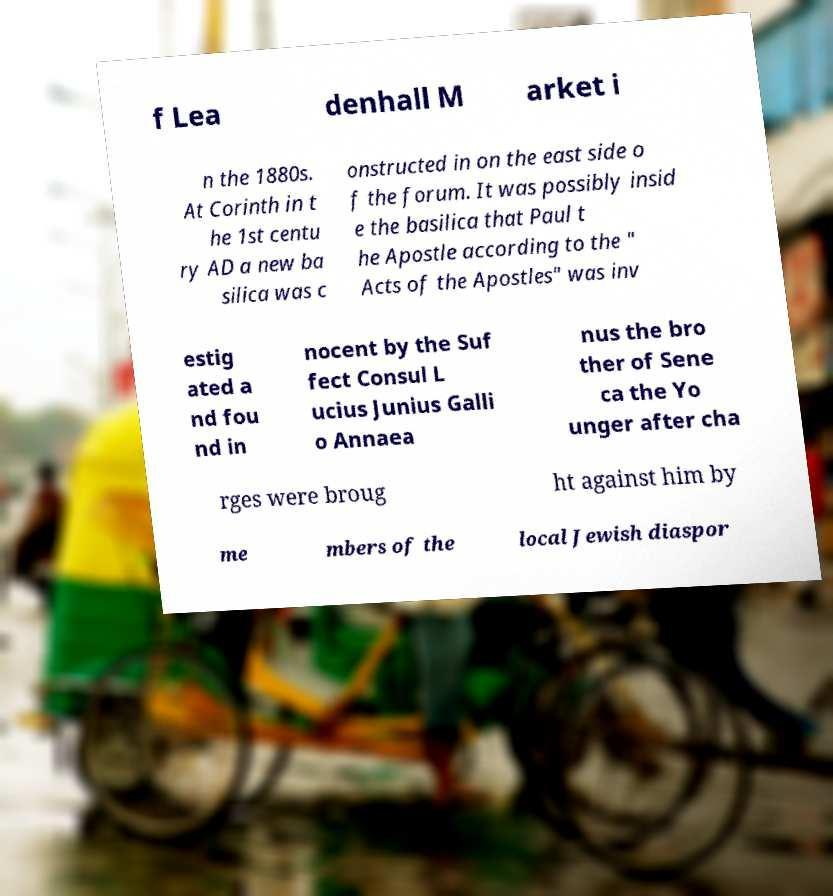Can you accurately transcribe the text from the provided image for me? f Lea denhall M arket i n the 1880s. At Corinth in t he 1st centu ry AD a new ba silica was c onstructed in on the east side o f the forum. It was possibly insid e the basilica that Paul t he Apostle according to the " Acts of the Apostles" was inv estig ated a nd fou nd in nocent by the Suf fect Consul L ucius Junius Galli o Annaea nus the bro ther of Sene ca the Yo unger after cha rges were broug ht against him by me mbers of the local Jewish diaspor 